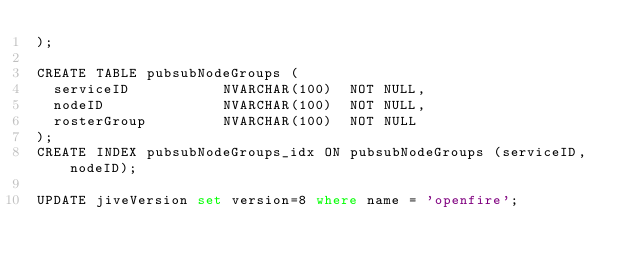Convert code to text. <code><loc_0><loc_0><loc_500><loc_500><_SQL_>);

CREATE TABLE pubsubNodeGroups (
  serviceID           NVARCHAR(100)  NOT NULL,
  nodeID              NVARCHAR(100)  NOT NULL,
  rosterGroup         NVARCHAR(100)  NOT NULL
);
CREATE INDEX pubsubNodeGroups_idx ON pubsubNodeGroups (serviceID, nodeID);

UPDATE jiveVersion set version=8 where name = 'openfire';
</code> 